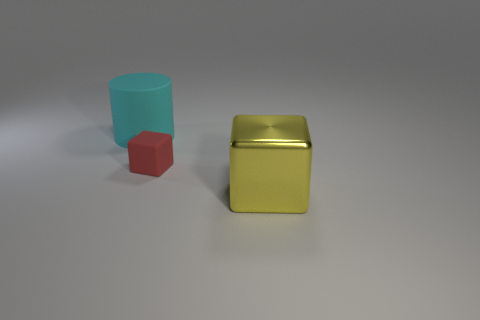Does the matte object in front of the cyan object have the same size as the yellow metallic thing?
Make the answer very short. No. Is the color of the metal block the same as the tiny rubber object?
Offer a very short reply. No. What number of metallic objects are there?
Keep it short and to the point. 1. How many blocks are small red rubber things or yellow metallic objects?
Give a very brief answer. 2. How many matte cubes are behind the rubber object that is to the left of the matte block?
Offer a very short reply. 0. Is the small red block made of the same material as the yellow block?
Ensure brevity in your answer.  No. Is there a tiny brown block that has the same material as the red thing?
Provide a succinct answer. No. There is a big thing to the right of the thing behind the block that is behind the yellow object; what color is it?
Provide a short and direct response. Yellow. What number of cyan things are either big metallic cubes or blocks?
Provide a short and direct response. 0. What number of other rubber objects are the same shape as the big matte thing?
Offer a terse response. 0. 